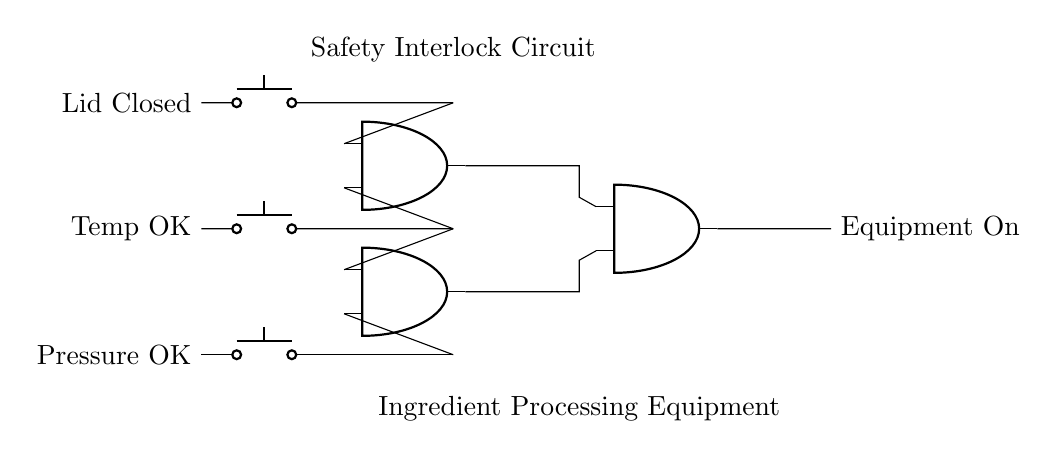What are the input conditions for the AND gates? The input conditions consist of three switches: Lid Closed, Temp OK, and Pressure OK. Each switch represents a condition that needs to be met for the equipment to operate.
Answer: Lid Closed, Temp OK, Pressure OK How many AND gates are present in the circuit? The circuit diagram shows three AND gates connected in series through their outputs. Each gate processes multiple inputs related to the safety conditions.
Answer: Three What is the output of the safety interlock circuit? The output of the circuit is "Equipment On," indicating the condition under which the equipment will be activated when all input conditions are met.
Answer: Equipment On What logic operation do the AND gates perform? The AND gates perform a logical multiplication of the input conditions to ensure that all conditions must be true for the output to be active. This means that if any condition is false, the output will remain inactive.
Answer: Logical multiplication What happens if one of the inputs is not satisfied? If any one of the inputs (Lid Closed, Temp OK, or Pressure OK) is not satisfied, the corresponding AND gate will output false, causing the entire circuit to disable the "Equipment On." The safety interlock prevents operation under unsafe conditions.
Answer: Equipment Off 